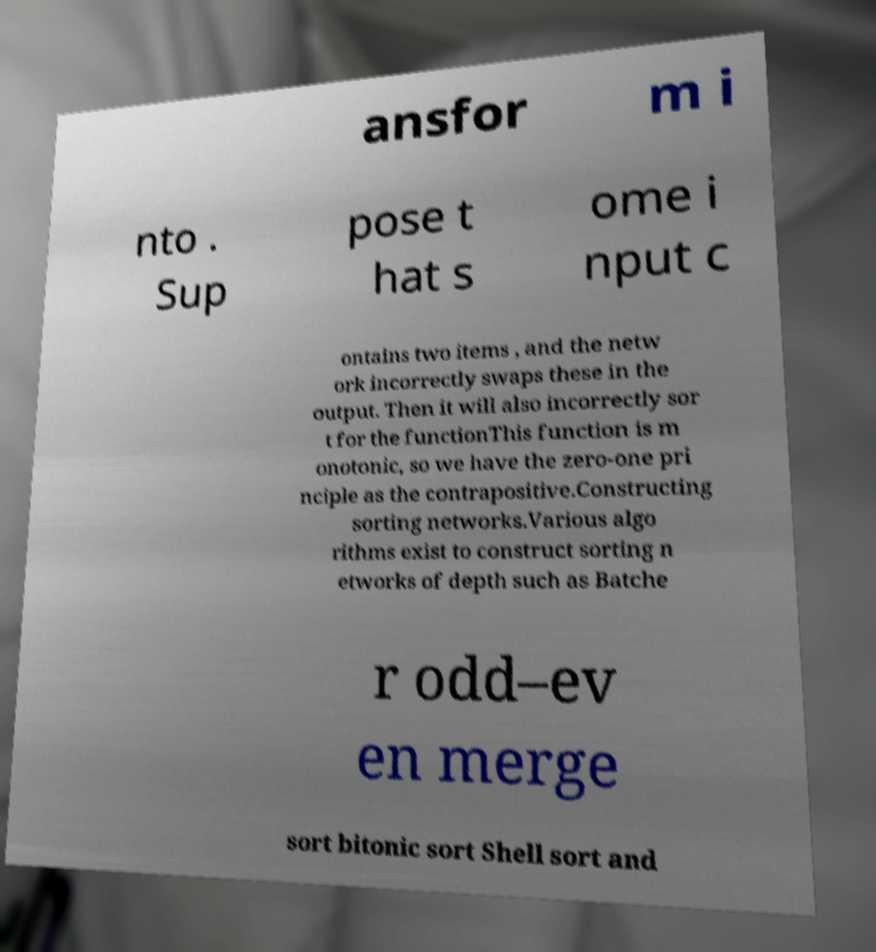Could you assist in decoding the text presented in this image and type it out clearly? ansfor m i nto . Sup pose t hat s ome i nput c ontains two items , and the netw ork incorrectly swaps these in the output. Then it will also incorrectly sor t for the functionThis function is m onotonic, so we have the zero-one pri nciple as the contrapositive.Constructing sorting networks.Various algo rithms exist to construct sorting n etworks of depth such as Batche r odd–ev en merge sort bitonic sort Shell sort and 